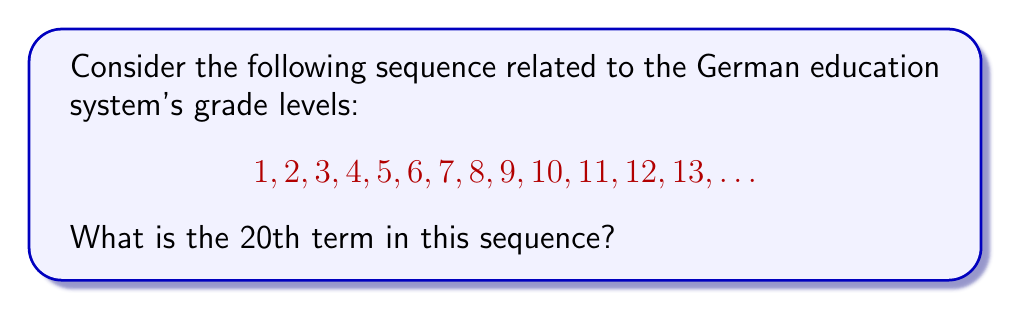Can you solve this math problem? Let's analyze this sequence step-by-step:

1) The German education system typically has 13 grade levels, starting from 1 and ending at 13 (Abitur).

2) We can observe that the sequence starts with 1 and increases by 1 for each subsequent term up to 13.

3) After 13, the pattern seems to repeat. This is because after completing the 13th grade, students typically move on to university or vocational training, which is not part of the standard grade level system.

4) We can express this mathematically as:

   $a_n = (n - 1) \bmod 13 + 1$

   Where $a_n$ is the nth term of the sequence and $\bmod$ is the modulo operation.

5) To find the 20th term, we plug in $n = 20$:

   $a_{20} = (20 - 1) \bmod 13 + 1$
   $a_{20} = 19 \bmod 13 + 1$
   $a_{20} = 6 + 1 = 7$

Therefore, the 20th term in the sequence is 7.
Answer: 7 